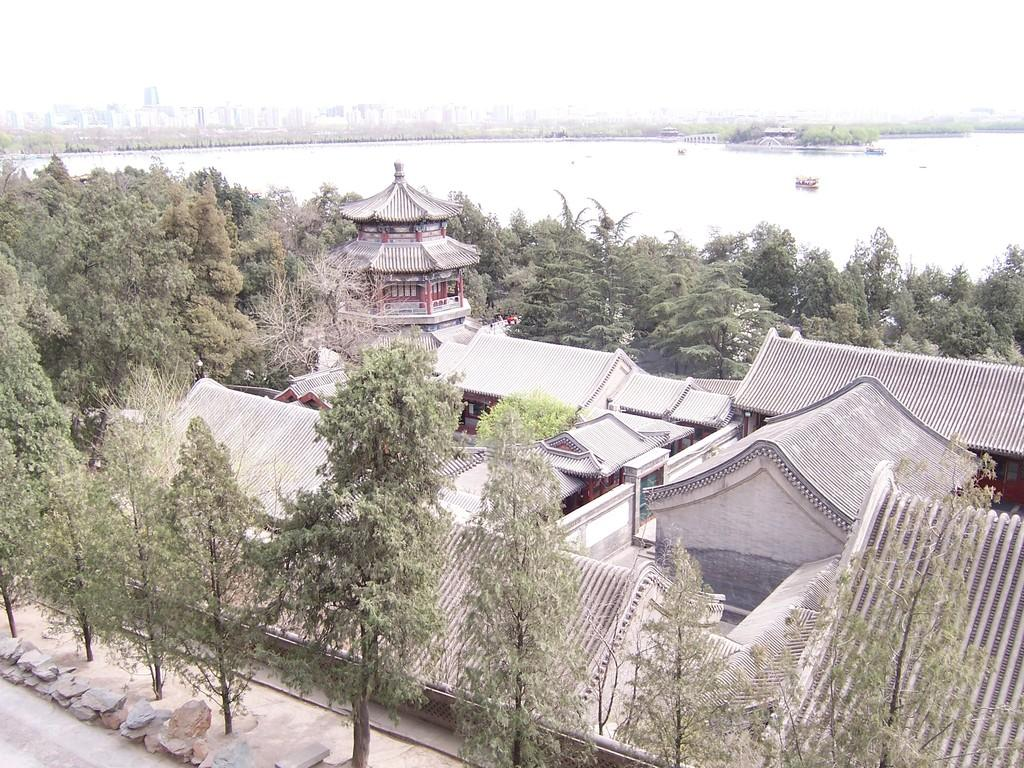What type of structures can be seen in the image? There are many buildings in the image. What other natural elements are present in the image? There are trees in the image. What part of a person's body is visible in the image? A back side is visible in the image. What body of water can be seen in the image? There is a lake in the image. What type of verse is being recited by the trees in the image? There is no verse being recited by the trees in the image, as trees do not have the ability to recite verses. 